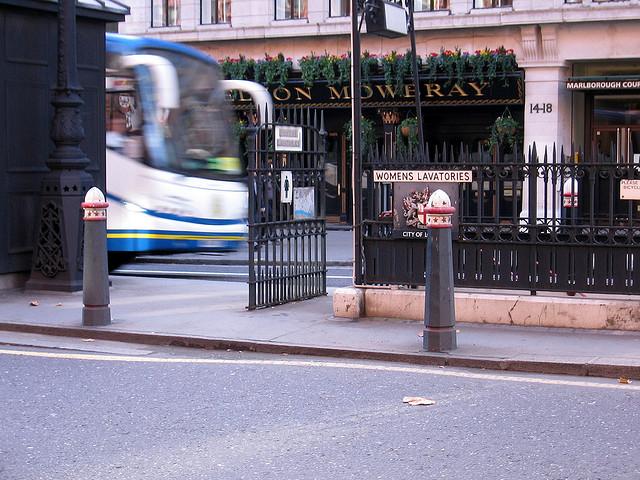Why is the image of the vehicle blurred?
Answer briefly. It's moving. Is the gate open?
Write a very short answer. Yes. Is this a city or countryside?
Short answer required. City. 